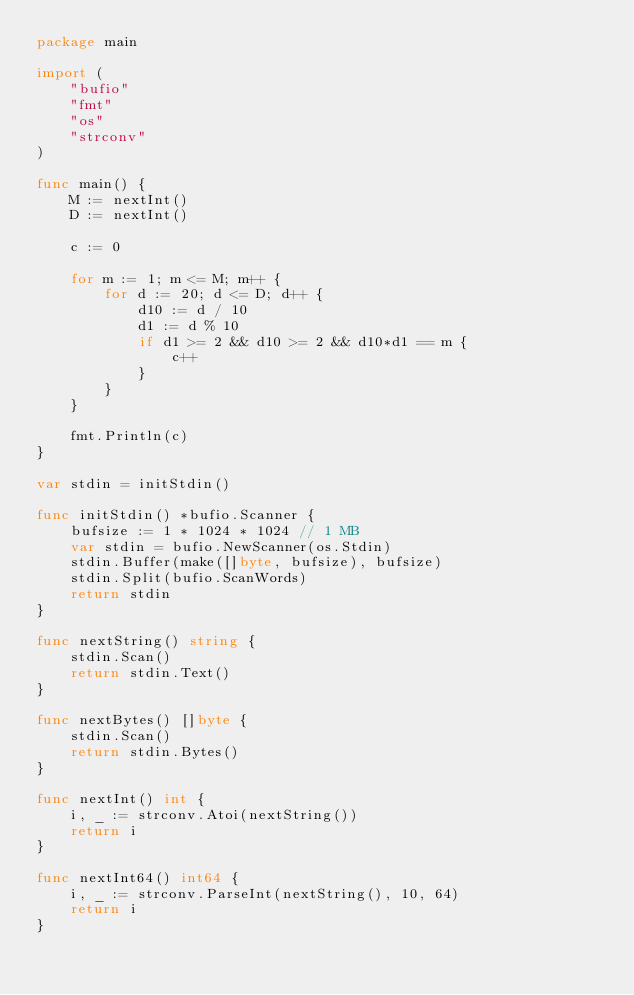Convert code to text. <code><loc_0><loc_0><loc_500><loc_500><_Go_>package main

import (
	"bufio"
	"fmt"
	"os"
	"strconv"
)

func main() {
	M := nextInt()
	D := nextInt()

	c := 0

	for m := 1; m <= M; m++ {
		for d := 20; d <= D; d++ {
			d10 := d / 10
			d1 := d % 10
			if d1 >= 2 && d10 >= 2 && d10*d1 == m {
				c++
			}
		}
	}

	fmt.Println(c)
}

var stdin = initStdin()

func initStdin() *bufio.Scanner {
	bufsize := 1 * 1024 * 1024 // 1 MB
	var stdin = bufio.NewScanner(os.Stdin)
	stdin.Buffer(make([]byte, bufsize), bufsize)
	stdin.Split(bufio.ScanWords)
	return stdin
}

func nextString() string {
	stdin.Scan()
	return stdin.Text()
}

func nextBytes() []byte {
	stdin.Scan()
	return stdin.Bytes()
}

func nextInt() int {
	i, _ := strconv.Atoi(nextString())
	return i
}

func nextInt64() int64 {
	i, _ := strconv.ParseInt(nextString(), 10, 64)
	return i
}
</code> 